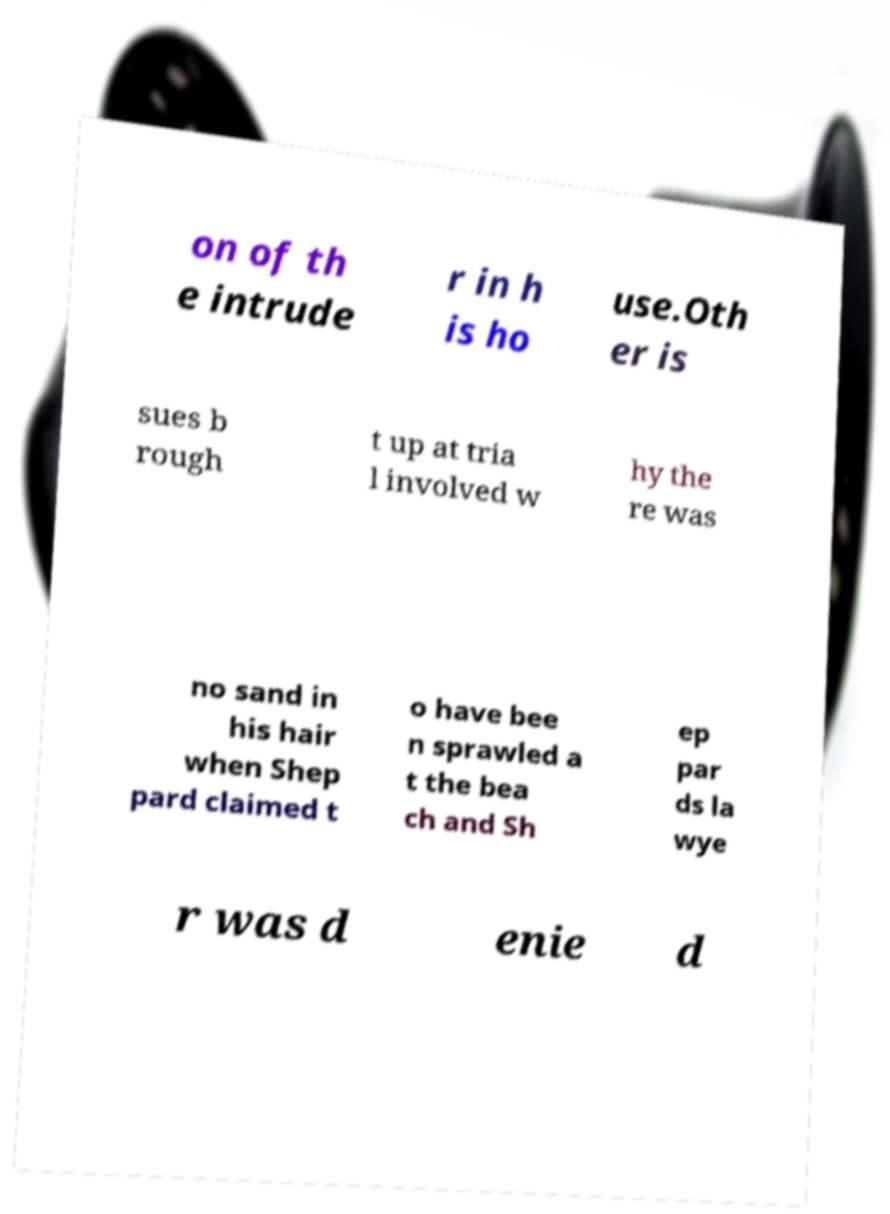For documentation purposes, I need the text within this image transcribed. Could you provide that? on of th e intrude r in h is ho use.Oth er is sues b rough t up at tria l involved w hy the re was no sand in his hair when Shep pard claimed t o have bee n sprawled a t the bea ch and Sh ep par ds la wye r was d enie d 